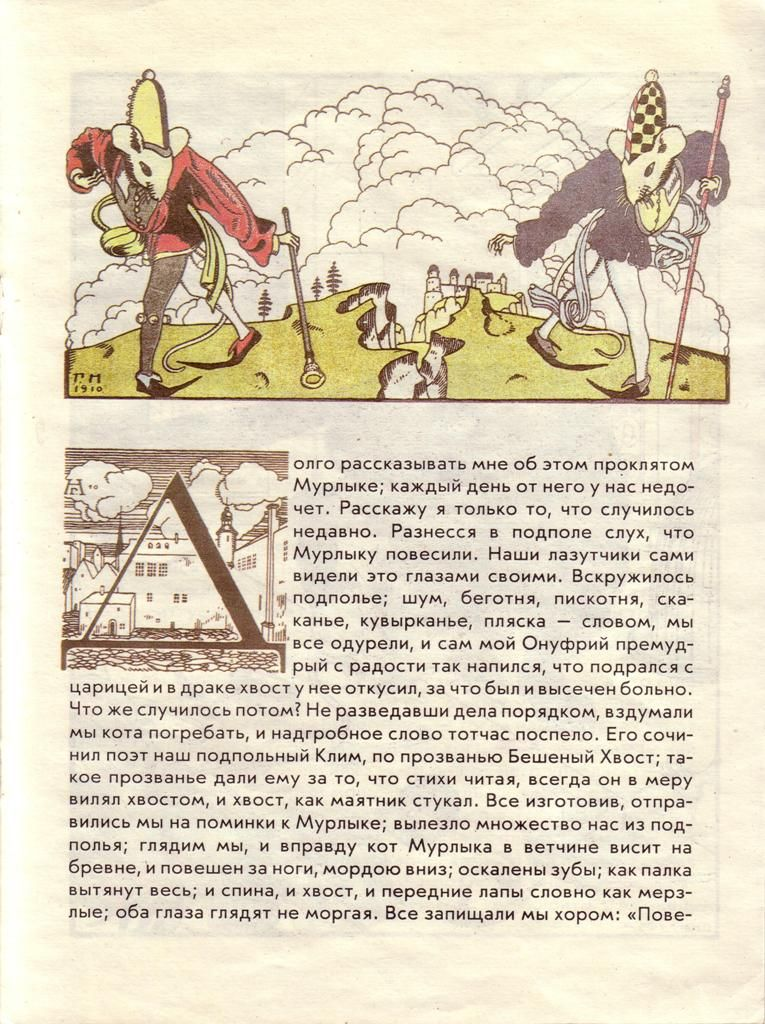Can you elaborate on the elements of the picture provided? The image is drawn in a whimsical, caricature-like style, likely intended for humorous or satirical purposes rather than a direct historical recount. It depicts two exaggerated figures dressed as knights, one in a vivid red outfit and the other in blue, each adorned with comically large and impractical hats that resemble a mix of medieval and renaissance styles. The knight in red wields a short sword while the one in blue carries a long lance. Both knights are shown with oversized, stylized horses in a fantastical landscape that includes softly rolling hills and scattered trees, creating a playful and dynamic scene. In the background, a quaint castle completes the fantastical medieval setting. This illustration seems to play with historical themes to entertain rather than educate. 